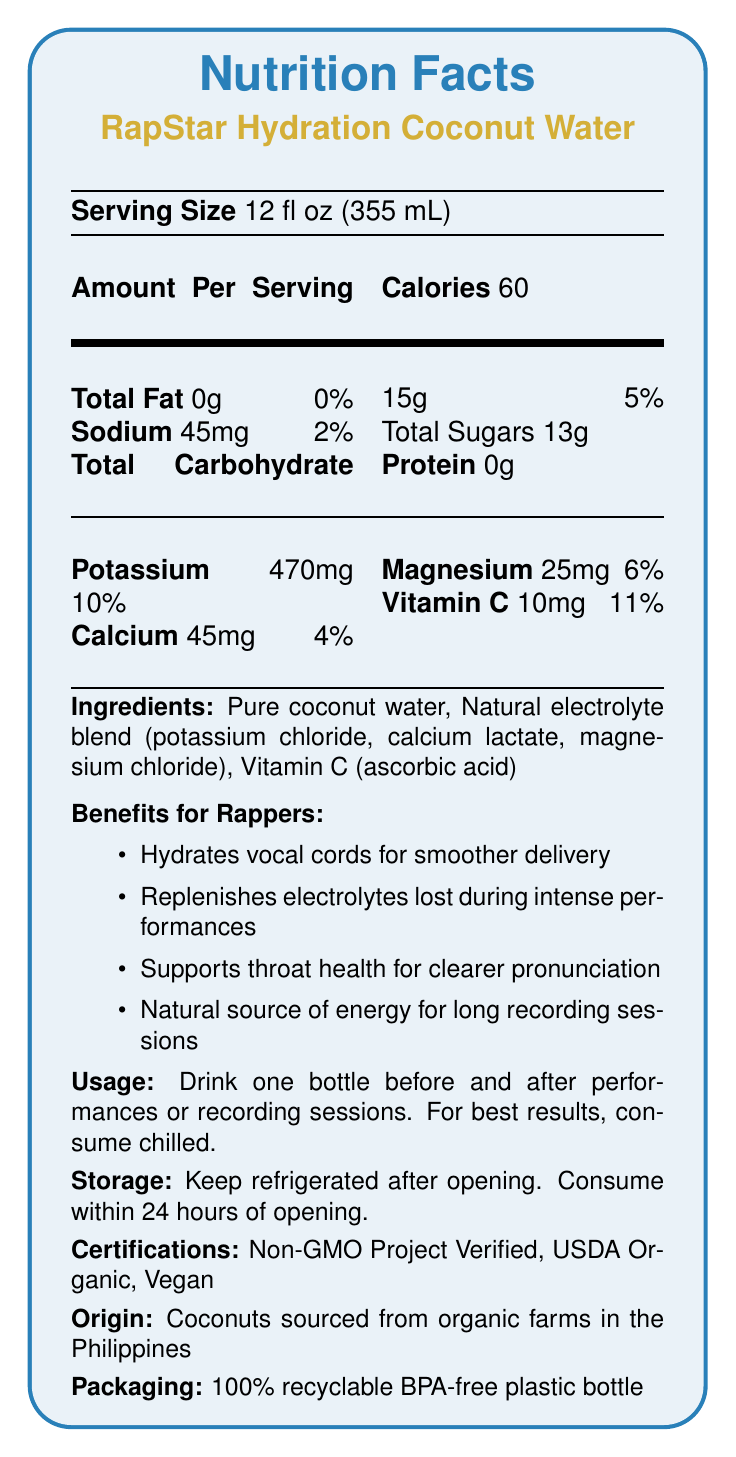what is the serving size of RapStar Hydration Coconut Water? The serving size is clearly listed at the beginning of the document as 12 fl oz (355 mL).
Answer: 12 fl oz (355 mL) how many calories are in a serving? The nutrition facts section shows that there are 60 calories per serving.
Answer: 60 what is the amount of sodium per serving? The amount of sodium per serving is specified as 45mg.
Answer: 45mg what percentage of the daily value is the calcium content? The document states that the calcium content per serving is 4% of the daily value.
Answer: 4% what ingredient is listed first in RapStar Hydration Coconut Water? The ingredients list indicates that the first ingredient is pure coconut water.
Answer: Pure coconut water what health benefits are mentioned for rappers? A. Hydrating vocal cords B. Increased stamina C. Enhanced vision D. Better hearing The benefits section specifically notes "Hydrates vocal cords for smoother delivery," which makes option A the correct choice.
Answer: A. Hydrating vocal cords which nutrient has the highest daily value percentage? A. Potassium B. Calcium C. Magnesium D. Vitamin C Potassium has a daily value percentage of 10%, which is the highest among the listed nutrients.
Answer: A. Potassium is RapStar Hydration Coconut Water suitable for vegans? The document mentions that the product is "Vegan" under the certifications section.
Answer: Yes what instructions are given regarding the consumption of the drink for best results? The usage instructions clearly advise to drink one bottle before and after performances or recording sessions, and to consume it chilled.
Answer: Drink one bottle before and after performances or recording sessions. For best results, consume chilled. summarize the document. The summary captures the main points and detailed information provided in the document.
Answer: This document provides detailed nutrition facts and other essential information for RapStar Hydration Coconut Water, including serving size, calorie count, and nutrient content. It outlines the ingredients, highlights specific benefits for rappers such as hydration and electrolyte replenishment, and offers usage and storage instructions. The product is certified as Non-GMO, USDA Organic, and Vegan, and comes in recyclable, BPA-free packaging sourced from the Philippines. where can the coconuts used in RapStar Hydration Coconut Water be sourced from? The origin section of the document states that the coconuts are sourced from organic farms in the Philippines.
Answer: The Philippines how much sugar is there in a serving? The total carbohydrate section mentions that there are 13g of total sugars per serving.
Answer: 13g how long should the product be consumed after opening? The storage instructions specify that the product should be consumed within 24 hours of opening.
Answer: Within 24 hours how is RapStar Hydration Coconut Water beneficial for the throat? The benefits for rappers include supporting throat health for clearer pronunciation.
Answer: Supports throat health for clearer pronunciation does the label provide information on the amount of Vitamin D per serving? The document does not mention Vitamin D; hence, no information is provided regarding Vitamin D content.
Answer: Not enough information 